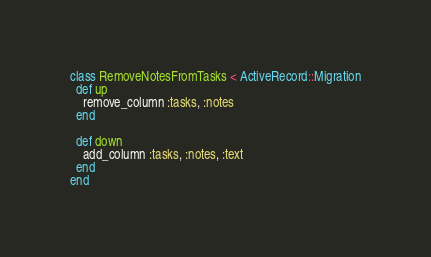<code> <loc_0><loc_0><loc_500><loc_500><_Ruby_>class RemoveNotesFromTasks < ActiveRecord::Migration
  def up
    remove_column :tasks, :notes
  end

  def down
    add_column :tasks, :notes, :text
  end
end
</code> 